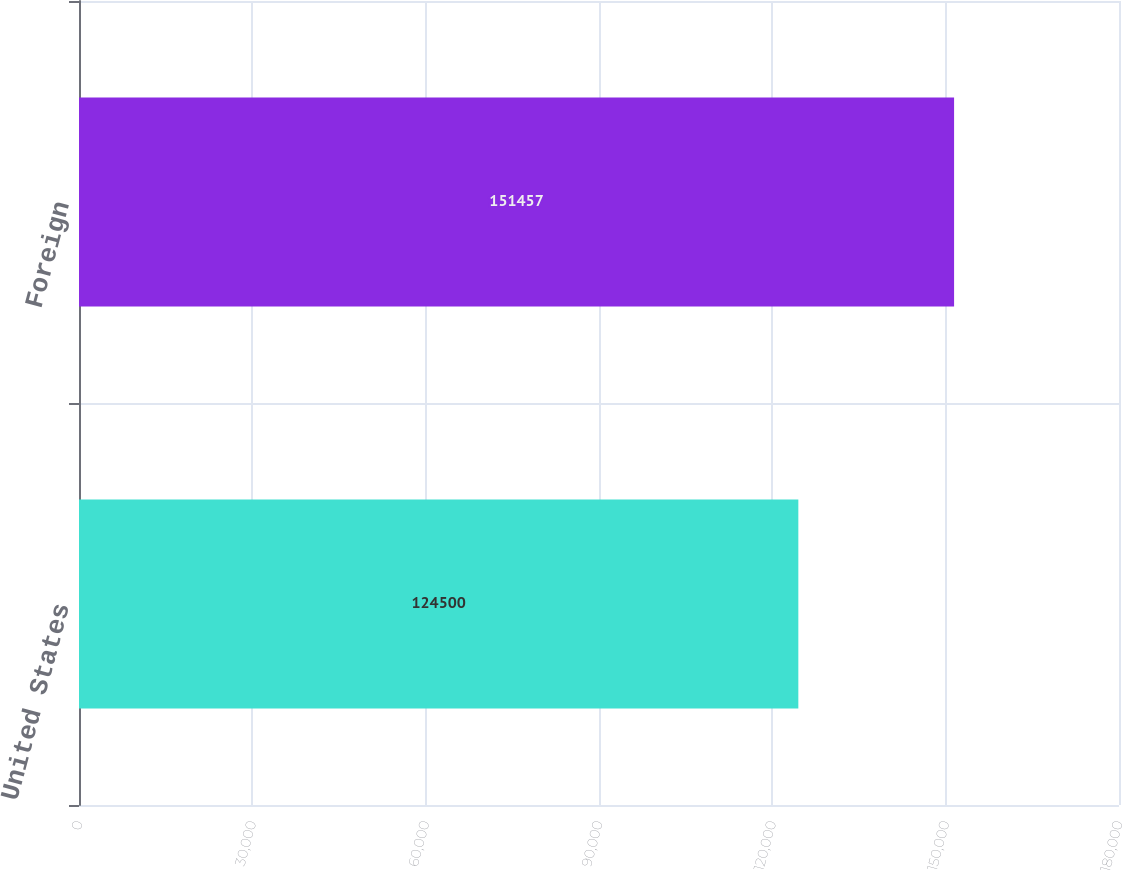Convert chart. <chart><loc_0><loc_0><loc_500><loc_500><bar_chart><fcel>United States<fcel>Foreign<nl><fcel>124500<fcel>151457<nl></chart> 